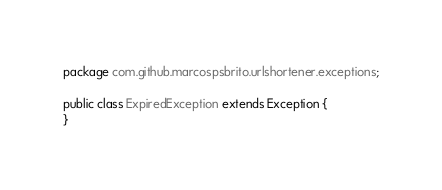Convert code to text. <code><loc_0><loc_0><loc_500><loc_500><_Java_>package com.github.marcospsbrito.urlshortener.exceptions;

public class ExpiredException extends Exception {
}
</code> 